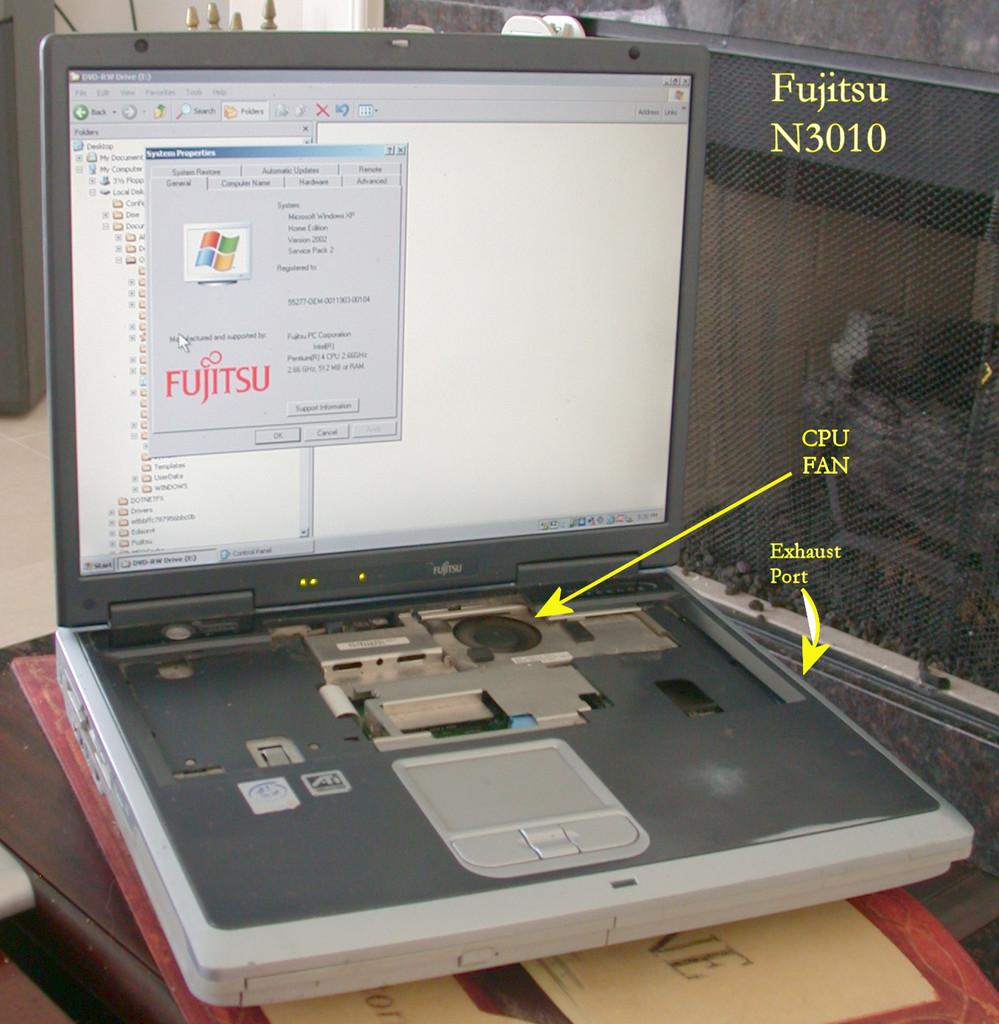<image>
Render a clear and concise summary of the photo. An old Fujitsu laptop has the CPU fan pointed out. 